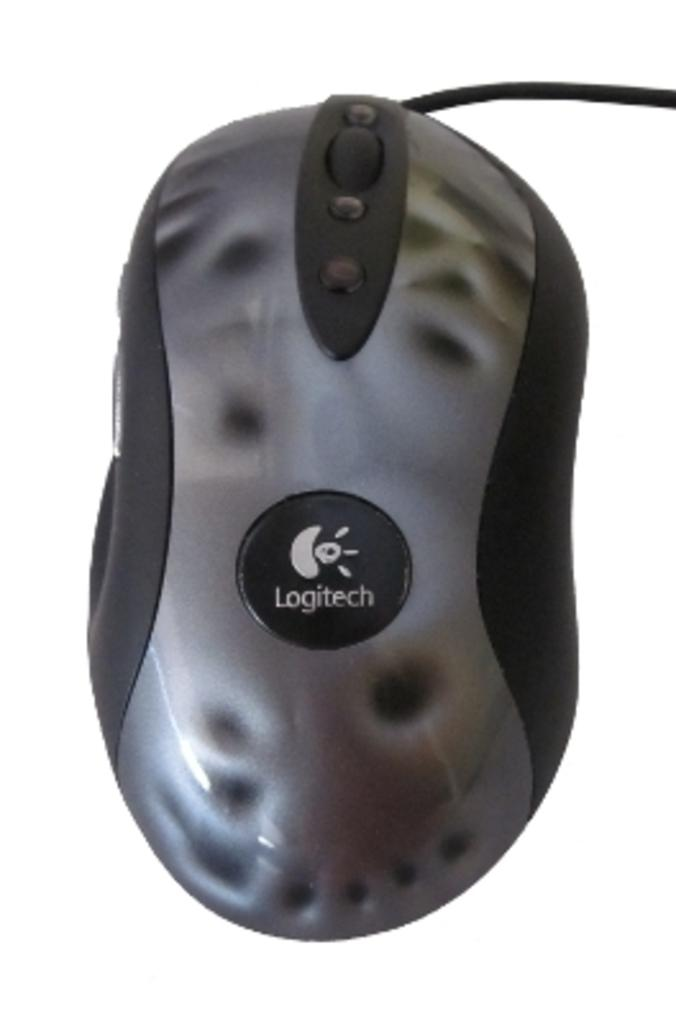What is the main subject in the center of the image? There is a mouse in the center of the image. What type of wound can be seen on the mouse's back in the image? There is no wound visible on the mouse in the image. What type of blade is the mouse holding in the image? There is no blade present in the image; the mouse is not holding anything. 